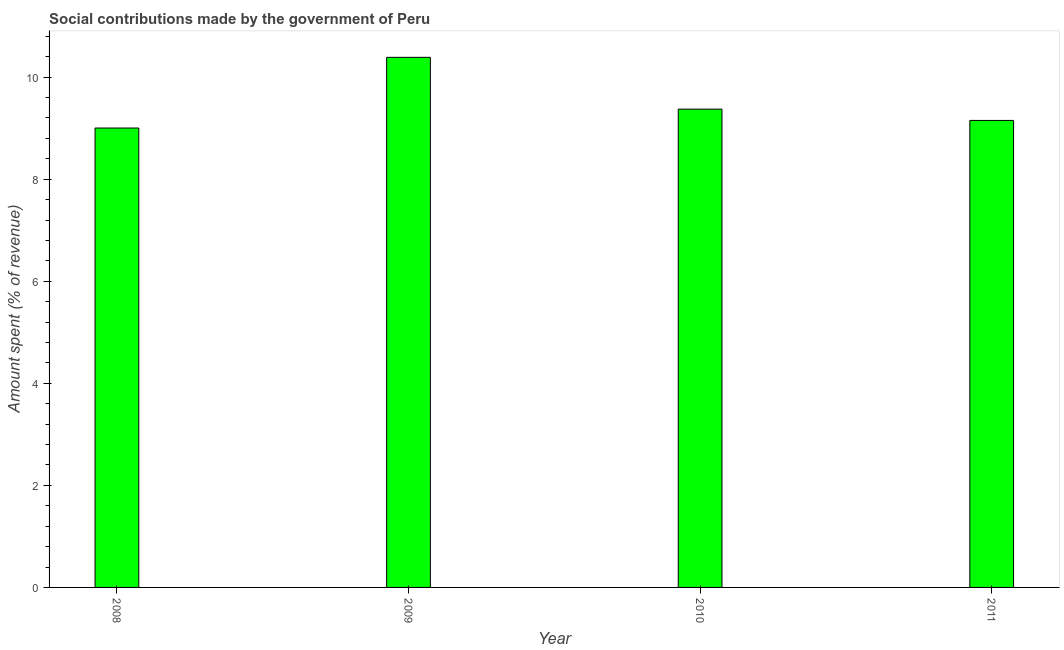Does the graph contain any zero values?
Provide a short and direct response. No. Does the graph contain grids?
Make the answer very short. No. What is the title of the graph?
Offer a terse response. Social contributions made by the government of Peru. What is the label or title of the X-axis?
Make the answer very short. Year. What is the label or title of the Y-axis?
Offer a terse response. Amount spent (% of revenue). What is the amount spent in making social contributions in 2008?
Make the answer very short. 9. Across all years, what is the maximum amount spent in making social contributions?
Provide a short and direct response. 10.39. Across all years, what is the minimum amount spent in making social contributions?
Offer a very short reply. 9. In which year was the amount spent in making social contributions maximum?
Offer a terse response. 2009. What is the sum of the amount spent in making social contributions?
Your answer should be very brief. 37.92. What is the difference between the amount spent in making social contributions in 2008 and 2010?
Provide a succinct answer. -0.37. What is the average amount spent in making social contributions per year?
Ensure brevity in your answer.  9.48. What is the median amount spent in making social contributions?
Your answer should be very brief. 9.26. Do a majority of the years between 2009 and 2011 (inclusive) have amount spent in making social contributions greater than 3.6 %?
Ensure brevity in your answer.  Yes. What is the ratio of the amount spent in making social contributions in 2008 to that in 2011?
Your answer should be compact. 0.98. What is the difference between the highest and the second highest amount spent in making social contributions?
Ensure brevity in your answer.  1.02. Is the sum of the amount spent in making social contributions in 2010 and 2011 greater than the maximum amount spent in making social contributions across all years?
Offer a very short reply. Yes. What is the difference between the highest and the lowest amount spent in making social contributions?
Ensure brevity in your answer.  1.39. In how many years, is the amount spent in making social contributions greater than the average amount spent in making social contributions taken over all years?
Give a very brief answer. 1. Are all the bars in the graph horizontal?
Offer a terse response. No. How many years are there in the graph?
Ensure brevity in your answer.  4. What is the difference between two consecutive major ticks on the Y-axis?
Provide a short and direct response. 2. Are the values on the major ticks of Y-axis written in scientific E-notation?
Offer a terse response. No. What is the Amount spent (% of revenue) of 2008?
Offer a very short reply. 9. What is the Amount spent (% of revenue) in 2009?
Provide a succinct answer. 10.39. What is the Amount spent (% of revenue) in 2010?
Provide a succinct answer. 9.37. What is the Amount spent (% of revenue) in 2011?
Offer a very short reply. 9.15. What is the difference between the Amount spent (% of revenue) in 2008 and 2009?
Your answer should be very brief. -1.39. What is the difference between the Amount spent (% of revenue) in 2008 and 2010?
Offer a very short reply. -0.37. What is the difference between the Amount spent (% of revenue) in 2008 and 2011?
Your answer should be compact. -0.15. What is the difference between the Amount spent (% of revenue) in 2009 and 2010?
Provide a short and direct response. 1.02. What is the difference between the Amount spent (% of revenue) in 2009 and 2011?
Keep it short and to the point. 1.24. What is the difference between the Amount spent (% of revenue) in 2010 and 2011?
Offer a terse response. 0.22. What is the ratio of the Amount spent (% of revenue) in 2008 to that in 2009?
Give a very brief answer. 0.87. What is the ratio of the Amount spent (% of revenue) in 2009 to that in 2010?
Keep it short and to the point. 1.11. What is the ratio of the Amount spent (% of revenue) in 2009 to that in 2011?
Keep it short and to the point. 1.14. 